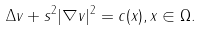Convert formula to latex. <formula><loc_0><loc_0><loc_500><loc_500>\Delta v + s ^ { 2 } | \nabla v | ^ { 2 } = c ( x ) , x \in \Omega .</formula> 